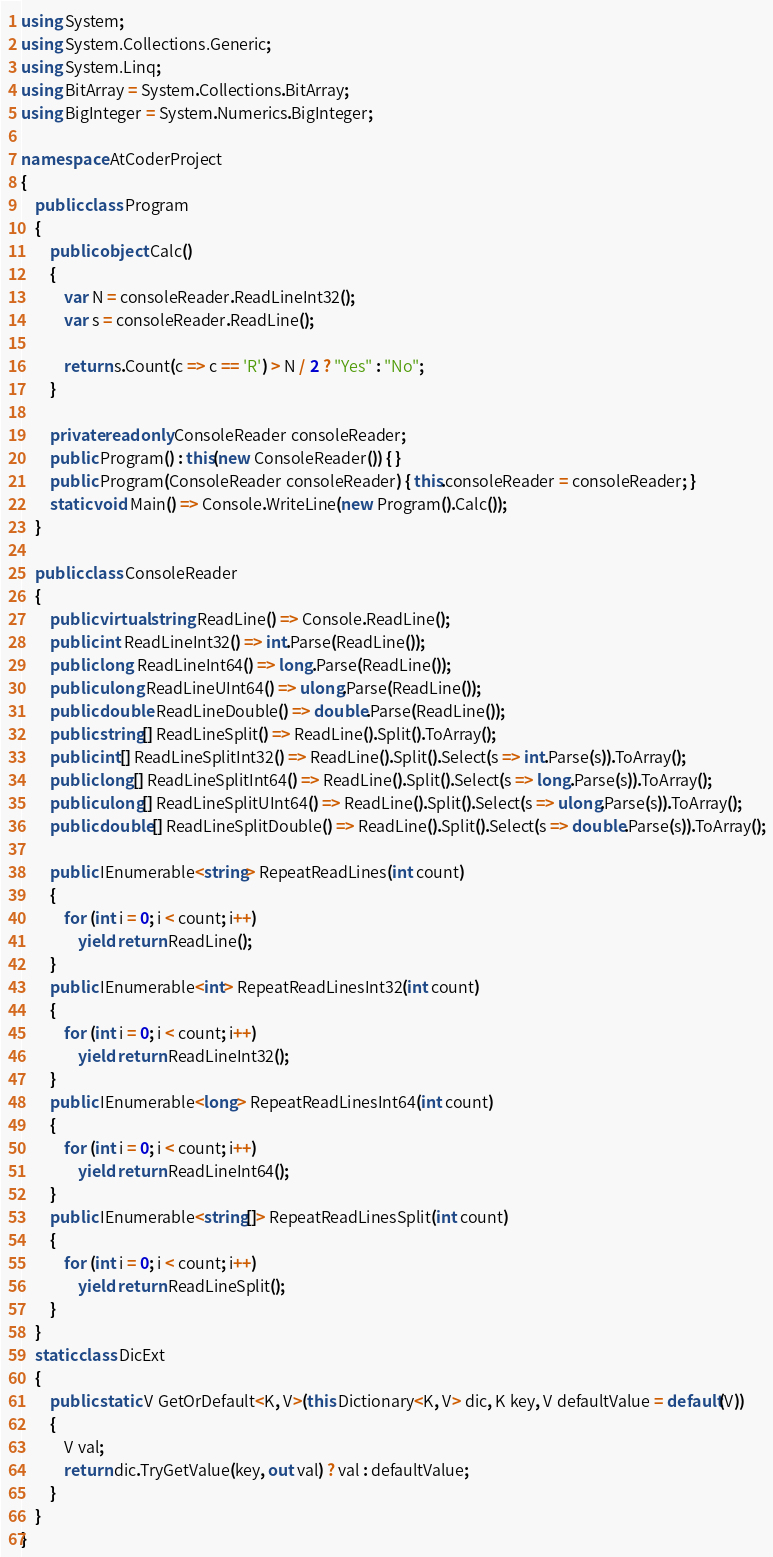<code> <loc_0><loc_0><loc_500><loc_500><_C#_>using System;
using System.Collections.Generic;
using System.Linq;
using BitArray = System.Collections.BitArray;
using BigInteger = System.Numerics.BigInteger;

namespace AtCoderProject
{
    public class Program
    {
        public object Calc()
        {
            var N = consoleReader.ReadLineInt32();
            var s = consoleReader.ReadLine();

            return s.Count(c => c == 'R') > N / 2 ? "Yes" : "No";
        }

        private readonly ConsoleReader consoleReader;
        public Program() : this(new ConsoleReader()) { }
        public Program(ConsoleReader consoleReader) { this.consoleReader = consoleReader; }
        static void Main() => Console.WriteLine(new Program().Calc());
    }

    public class ConsoleReader
    {
        public virtual string ReadLine() => Console.ReadLine();
        public int ReadLineInt32() => int.Parse(ReadLine());
        public long ReadLineInt64() => long.Parse(ReadLine());
        public ulong ReadLineUInt64() => ulong.Parse(ReadLine());
        public double ReadLineDouble() => double.Parse(ReadLine());
        public string[] ReadLineSplit() => ReadLine().Split().ToArray();
        public int[] ReadLineSplitInt32() => ReadLine().Split().Select(s => int.Parse(s)).ToArray();
        public long[] ReadLineSplitInt64() => ReadLine().Split().Select(s => long.Parse(s)).ToArray();
        public ulong[] ReadLineSplitUInt64() => ReadLine().Split().Select(s => ulong.Parse(s)).ToArray();
        public double[] ReadLineSplitDouble() => ReadLine().Split().Select(s => double.Parse(s)).ToArray();

        public IEnumerable<string> RepeatReadLines(int count)
        {
            for (int i = 0; i < count; i++)
                yield return ReadLine();
        }
        public IEnumerable<int> RepeatReadLinesInt32(int count)
        {
            for (int i = 0; i < count; i++)
                yield return ReadLineInt32();
        }
        public IEnumerable<long> RepeatReadLinesInt64(int count)
        {
            for (int i = 0; i < count; i++)
                yield return ReadLineInt64();
        }
        public IEnumerable<string[]> RepeatReadLinesSplit(int count)
        {
            for (int i = 0; i < count; i++)
                yield return ReadLineSplit();
        }
    }
    static class DicExt
    {
        public static V GetOrDefault<K, V>(this Dictionary<K, V> dic, K key, V defaultValue = default(V))
        {
            V val;
            return dic.TryGetValue(key, out val) ? val : defaultValue;
        }
    }
}
</code> 